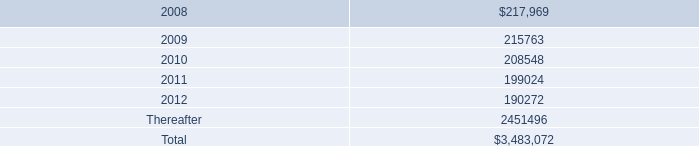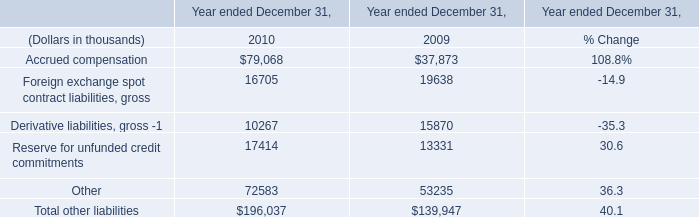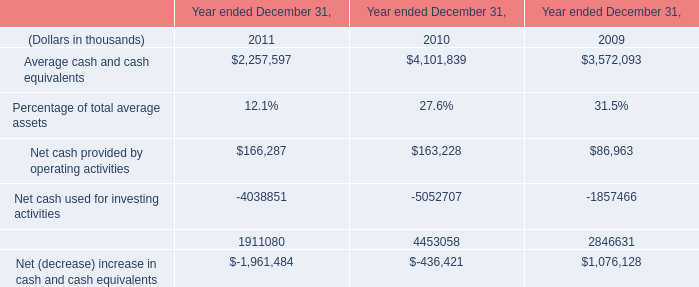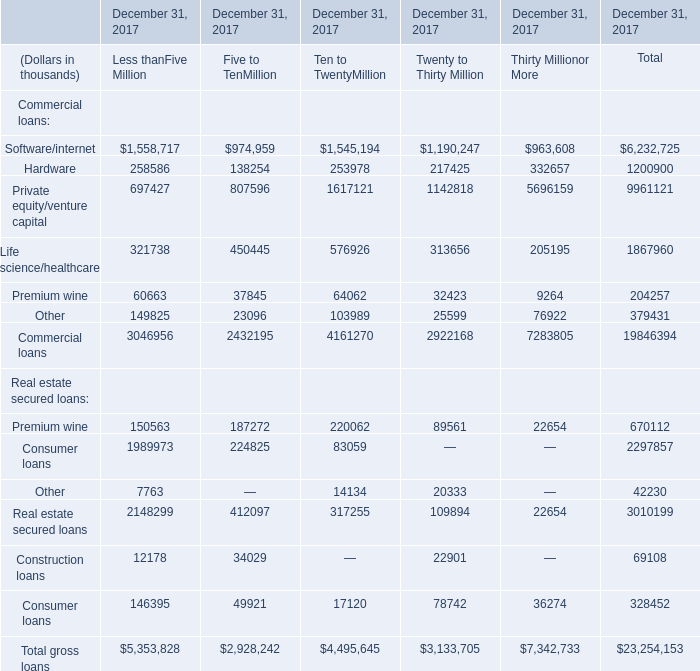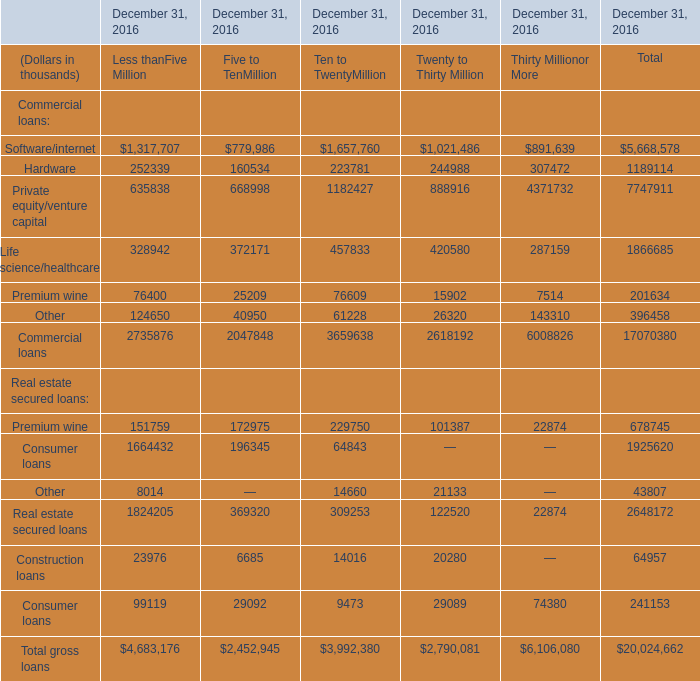What was the average of the Commercial loans in the year where Hardware is positive? (in thousand) 
Computations: (19846394 / 1)
Answer: 19846394.0. 